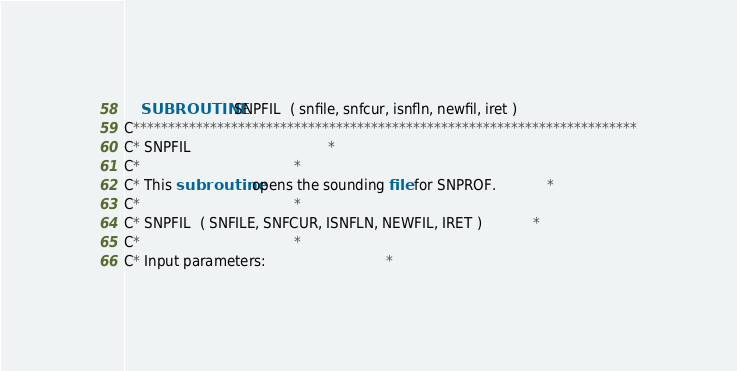Convert code to text. <code><loc_0><loc_0><loc_500><loc_500><_FORTRAN_>	SUBROUTINE SNPFIL  ( snfile, snfcur, isnfln, newfil, iret )
C************************************************************************
C* SNPFIL								*
C*									*
C* This subroutine opens the sounding file for SNPROF.			*
C*									*
C* SNPFIL  ( SNFILE, SNFCUR, ISNFLN, NEWFIL, IRET )			*
C*									*
C* Input parameters:							*</code> 